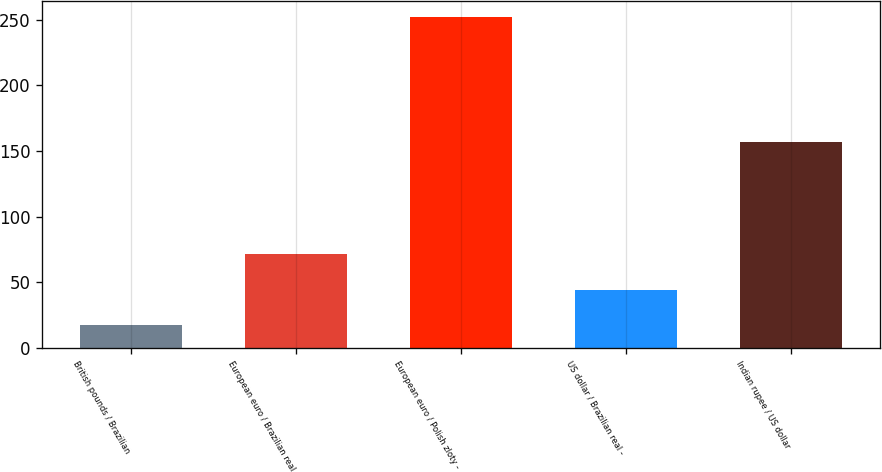Convert chart. <chart><loc_0><loc_0><loc_500><loc_500><bar_chart><fcel>British pounds / Brazilian<fcel>European euro / Brazilian real<fcel>European euro / Polish zloty -<fcel>US dollar / Brazilian real -<fcel>Indian rupee / US dollar<nl><fcel>17<fcel>71.6<fcel>252<fcel>44.3<fcel>157<nl></chart> 